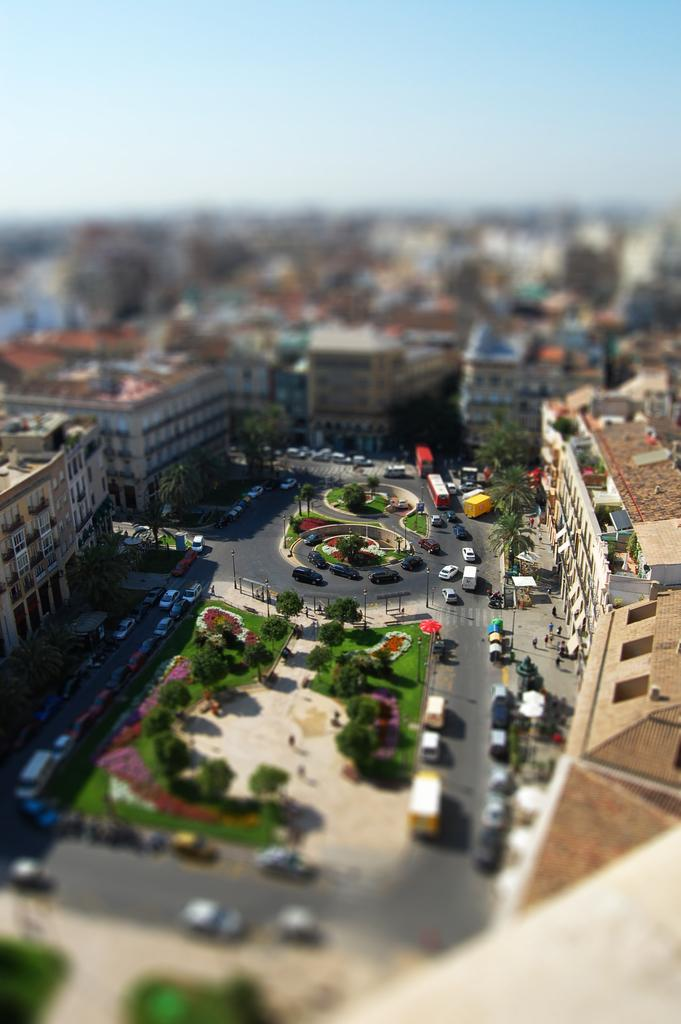What is the perspective of the image? The image is taken from a top view. What can be seen moving on the road in the image? Vehicles are moving on the road in the image. What type of vegetation is visible in the image? There are trees visible in the image. What type of area is present in the image? There is a garden in the image. What type of structures are present in the image? Poles and buildings are present in the image. What is visible in the background of the image? The sky is visible in the image. What type of apple is being combed in the image? There is no apple or comb present in the image. What type of brick is being used to build the garden in the image? There is no brick or construction activity present in the image; it features a garden with trees and vehicles on the road. 